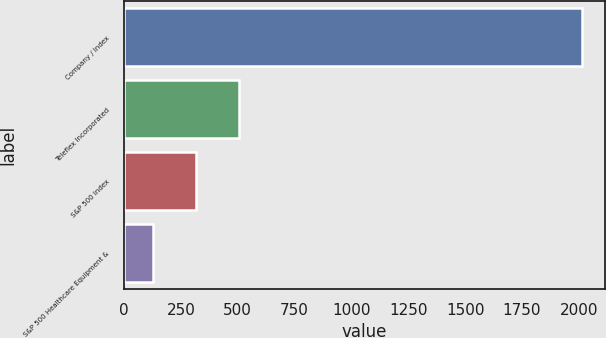<chart> <loc_0><loc_0><loc_500><loc_500><bar_chart><fcel>Company / Index<fcel>Teleflex Incorporated<fcel>S&P 500 Index<fcel>S&P 500 Healthcare Equipment &<nl><fcel>2013<fcel>505<fcel>316.5<fcel>128<nl></chart> 